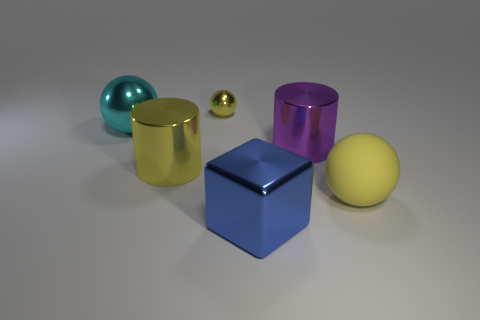Is there anything else that has the same material as the large yellow ball?
Offer a very short reply. No. What is the shape of the cyan metallic object?
Offer a terse response. Sphere. What is the size of the metal thing that is the same color as the small sphere?
Your answer should be very brief. Large. What number of metallic cubes are behind the yellow metal object that is in front of the large purple shiny thing?
Your response must be concise. 0. What number of other things are the same material as the big yellow sphere?
Your response must be concise. 0. Are the yellow thing behind the purple cylinder and the large sphere on the left side of the small yellow sphere made of the same material?
Offer a terse response. Yes. Is there anything else that is the same shape as the big blue shiny thing?
Provide a short and direct response. No. Does the large cyan thing have the same material as the yellow object that is behind the purple cylinder?
Your response must be concise. Yes. The big metal object that is to the right of the metallic object that is in front of the big yellow object that is in front of the large yellow metal cylinder is what color?
Give a very brief answer. Purple. There is a blue metal thing that is the same size as the rubber thing; what shape is it?
Ensure brevity in your answer.  Cube. 